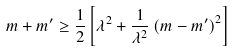Convert formula to latex. <formula><loc_0><loc_0><loc_500><loc_500>m + m ^ { \prime } \geq \frac { 1 } { 2 } \left [ \lambda ^ { 2 } + \frac { 1 } { \lambda ^ { 2 } } \left ( m - m ^ { \prime } \right ) ^ { 2 } \right ]</formula> 